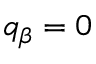Convert formula to latex. <formula><loc_0><loc_0><loc_500><loc_500>q _ { \beta } = 0</formula> 